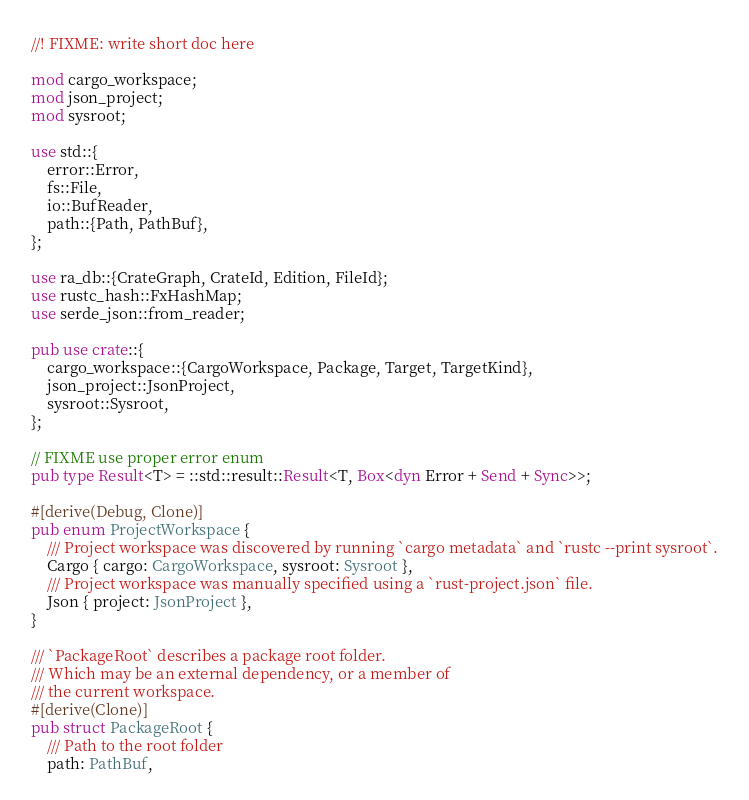<code> <loc_0><loc_0><loc_500><loc_500><_Rust_>//! FIXME: write short doc here

mod cargo_workspace;
mod json_project;
mod sysroot;

use std::{
    error::Error,
    fs::File,
    io::BufReader,
    path::{Path, PathBuf},
};

use ra_db::{CrateGraph, CrateId, Edition, FileId};
use rustc_hash::FxHashMap;
use serde_json::from_reader;

pub use crate::{
    cargo_workspace::{CargoWorkspace, Package, Target, TargetKind},
    json_project::JsonProject,
    sysroot::Sysroot,
};

// FIXME use proper error enum
pub type Result<T> = ::std::result::Result<T, Box<dyn Error + Send + Sync>>;

#[derive(Debug, Clone)]
pub enum ProjectWorkspace {
    /// Project workspace was discovered by running `cargo metadata` and `rustc --print sysroot`.
    Cargo { cargo: CargoWorkspace, sysroot: Sysroot },
    /// Project workspace was manually specified using a `rust-project.json` file.
    Json { project: JsonProject },
}

/// `PackageRoot` describes a package root folder.
/// Which may be an external dependency, or a member of
/// the current workspace.
#[derive(Clone)]
pub struct PackageRoot {
    /// Path to the root folder
    path: PathBuf,</code> 